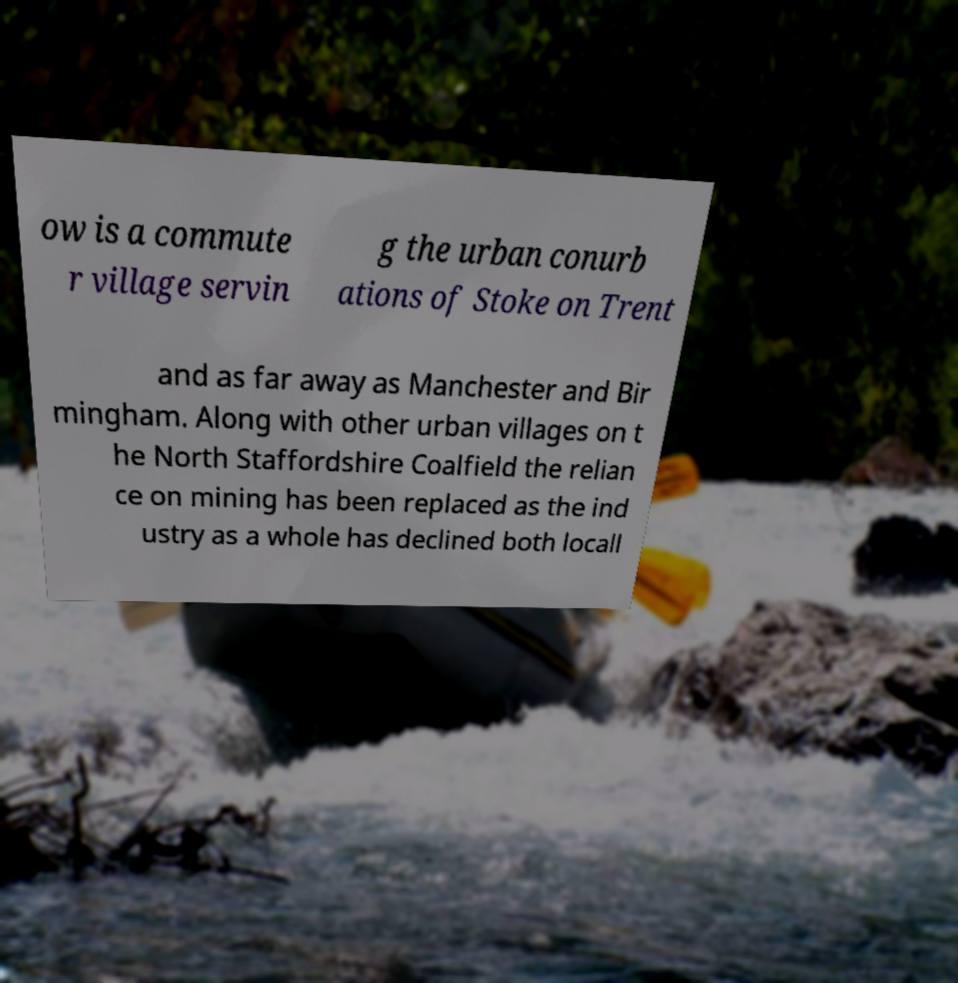There's text embedded in this image that I need extracted. Can you transcribe it verbatim? ow is a commute r village servin g the urban conurb ations of Stoke on Trent and as far away as Manchester and Bir mingham. Along with other urban villages on t he North Staffordshire Coalfield the relian ce on mining has been replaced as the ind ustry as a whole has declined both locall 